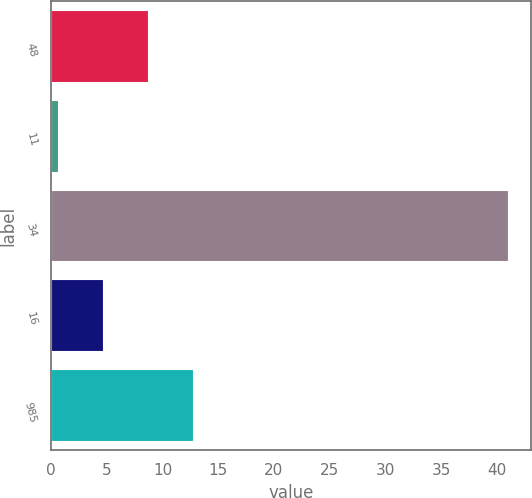<chart> <loc_0><loc_0><loc_500><loc_500><bar_chart><fcel>48<fcel>11<fcel>34<fcel>16<fcel>985<nl><fcel>8.68<fcel>0.6<fcel>41<fcel>4.64<fcel>12.72<nl></chart> 